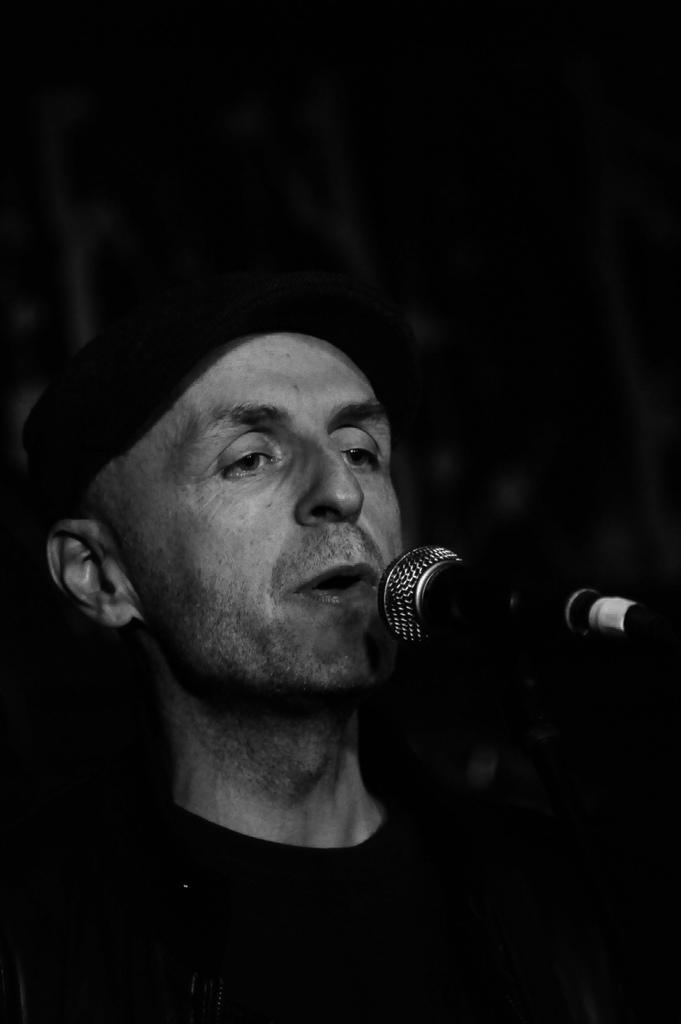Could you give a brief overview of what you see in this image? In this image I can see the person singing in front of the microphone and the image is in black and white. 